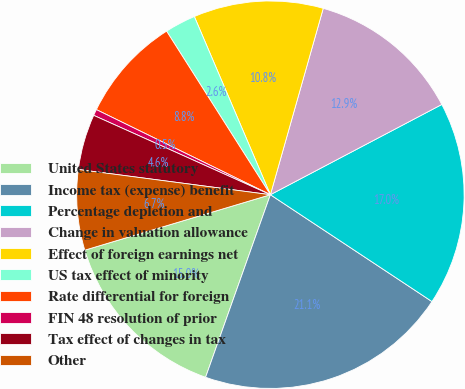Convert chart to OTSL. <chart><loc_0><loc_0><loc_500><loc_500><pie_chart><fcel>United States statutory<fcel>Income tax (expense) benefit<fcel>Percentage depletion and<fcel>Change in valuation allowance<fcel>Effect of foreign earnings net<fcel>US tax effect of minority<fcel>Rate differential for foreign<fcel>FIN 48 resolution of prior<fcel>Tax effect of changes in tax<fcel>Other<nl><fcel>14.95%<fcel>21.13%<fcel>17.01%<fcel>12.89%<fcel>10.82%<fcel>2.58%<fcel>8.76%<fcel>0.52%<fcel>4.64%<fcel>6.7%<nl></chart> 